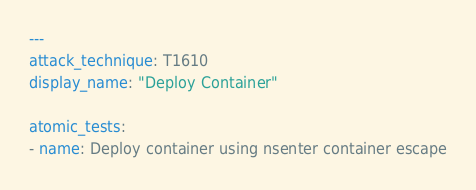<code> <loc_0><loc_0><loc_500><loc_500><_YAML_>---
attack_technique: T1610
display_name: "Deploy Container"

atomic_tests:
- name: Deploy container using nsenter container escape</code> 